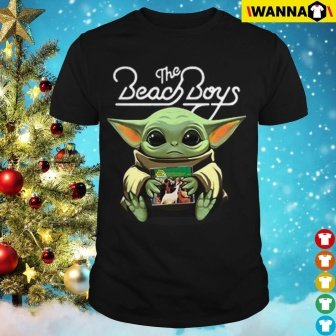What do you see happening in this image? In the center of the image, a black t-shirt is prominently displayed. The t-shirt is hung on a hanger, which is set against the backdrop of a beautifully decorated Christmas tree. The tree is adorned with red and gold ornaments, adding a festive touch to the scene.

The t-shirt itself features a unique graphic design. A green alien-like creature is depicted on the front of the shirt. This creature, with its large ears, is holding a small potted plant in its hands. The creature is also wearing a white shirt, and on this shirt, the words "The Beach Boys" are written in a black cursive font. The text is clearly visible and stands out against the white color of the creature's shirt.

The overall image presents a blend of everyday clothing with a touch of whimsy, set against a traditional holiday setting. The precise positioning of the t-shirt in front of the Christmas tree suggests a possible gift or a festive clothing choice for the holiday season. 